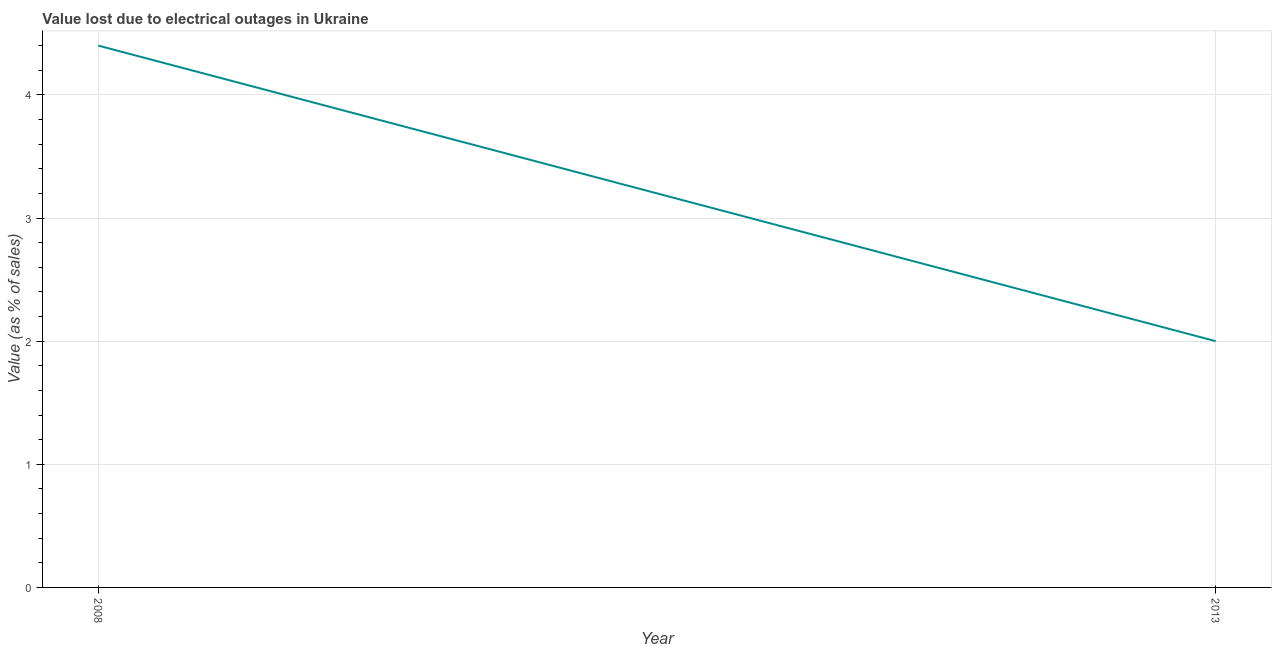In which year was the value lost due to electrical outages maximum?
Ensure brevity in your answer.  2008. What is the sum of the value lost due to electrical outages?
Provide a succinct answer. 6.4. What is the difference between the value lost due to electrical outages in 2008 and 2013?
Make the answer very short. 2.4. What is the average value lost due to electrical outages per year?
Your answer should be compact. 3.2. What is the median value lost due to electrical outages?
Offer a terse response. 3.2. Do a majority of the years between 2013 and 2008 (inclusive) have value lost due to electrical outages greater than 1.4 %?
Your answer should be compact. No. In how many years, is the value lost due to electrical outages greater than the average value lost due to electrical outages taken over all years?
Offer a terse response. 1. Does the value lost due to electrical outages monotonically increase over the years?
Your response must be concise. No. What is the difference between two consecutive major ticks on the Y-axis?
Provide a short and direct response. 1. What is the title of the graph?
Your answer should be very brief. Value lost due to electrical outages in Ukraine. What is the label or title of the Y-axis?
Give a very brief answer. Value (as % of sales). What is the Value (as % of sales) in 2013?
Give a very brief answer. 2. What is the difference between the Value (as % of sales) in 2008 and 2013?
Provide a succinct answer. 2.4. 